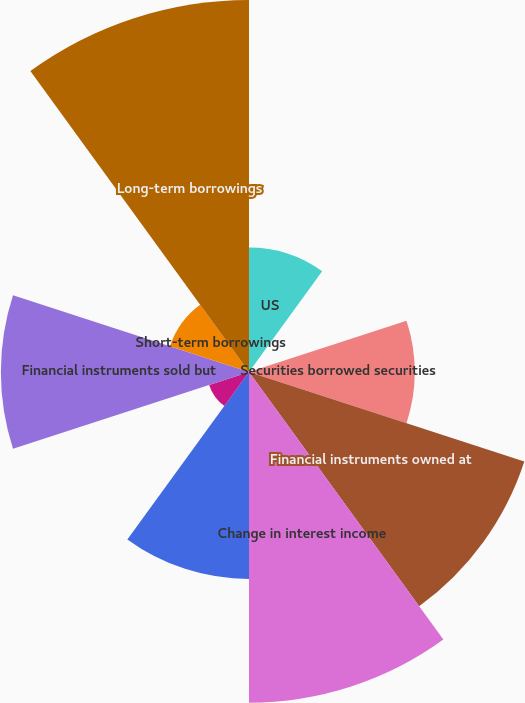<chart> <loc_0><loc_0><loc_500><loc_500><pie_chart><fcel>US<fcel>Non-US<fcel>Securities borrowed securities<fcel>Financial instruments owned at<fcel>Change in interest income<fcel>Interest-bearing deposits<fcel>Securities loaned and<fcel>Financial instruments sold but<fcel>Short-term borrowings<fcel>Long-term borrowings<nl><fcel>6.68%<fcel>0.03%<fcel>8.89%<fcel>15.54%<fcel>17.75%<fcel>11.11%<fcel>2.25%<fcel>13.32%<fcel>4.46%<fcel>19.97%<nl></chart> 